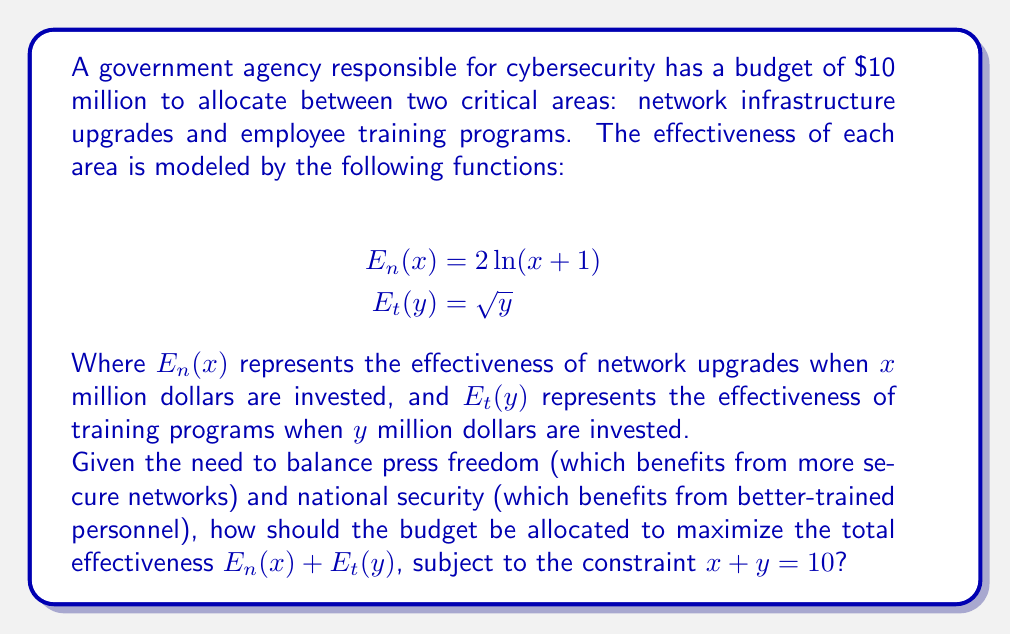Teach me how to tackle this problem. To solve this optimization problem, we can use the method of Lagrange multipliers. Let's follow these steps:

1) Define the objective function:
   $$ f(x,y) = E_n(x) + E_t(y) = 2\ln(x+1) + \sqrt{y} $$

2) Define the constraint:
   $$ g(x,y) = x + y - 10 = 0 $$

3) Form the Lagrangian:
   $$ L(x,y,\lambda) = f(x,y) - \lambda g(x,y) = 2\ln(x+1) + \sqrt{y} - \lambda(x + y - 10) $$

4) Take partial derivatives and set them to zero:
   $$ \frac{\partial L}{\partial x} = \frac{2}{x+1} - \lambda = 0 $$
   $$ \frac{\partial L}{\partial y} = \frac{1}{2\sqrt{y}} - \lambda = 0 $$
   $$ \frac{\partial L}{\partial \lambda} = x + y - 10 = 0 $$

5) From the first two equations:
   $$ \frac{2}{x+1} = \frac{1}{2\sqrt{y}} $$

6) This implies:
   $$ 4\sqrt{y} = x + 1 $$
   $$ 16y = (x+1)^2 $$

7) Substitute this into the constraint equation:
   $$ x + \frac{(x+1)^2}{16} = 10 $$

8) Solve this equation numerically (e.g., using Newton's method) to get:
   $$ x \approx 6.78 $$

9) Then:
   $$ y = 10 - x \approx 3.22 $$

10) Verify that these values satisfy the original equations.

Therefore, to maximize the total effectiveness, approximately $6.78 million should be allocated to network upgrades and $3.22 million to training programs.
Answer: Allocate approximately $6.78 million to network infrastructure upgrades and $3.22 million to employee training programs. 